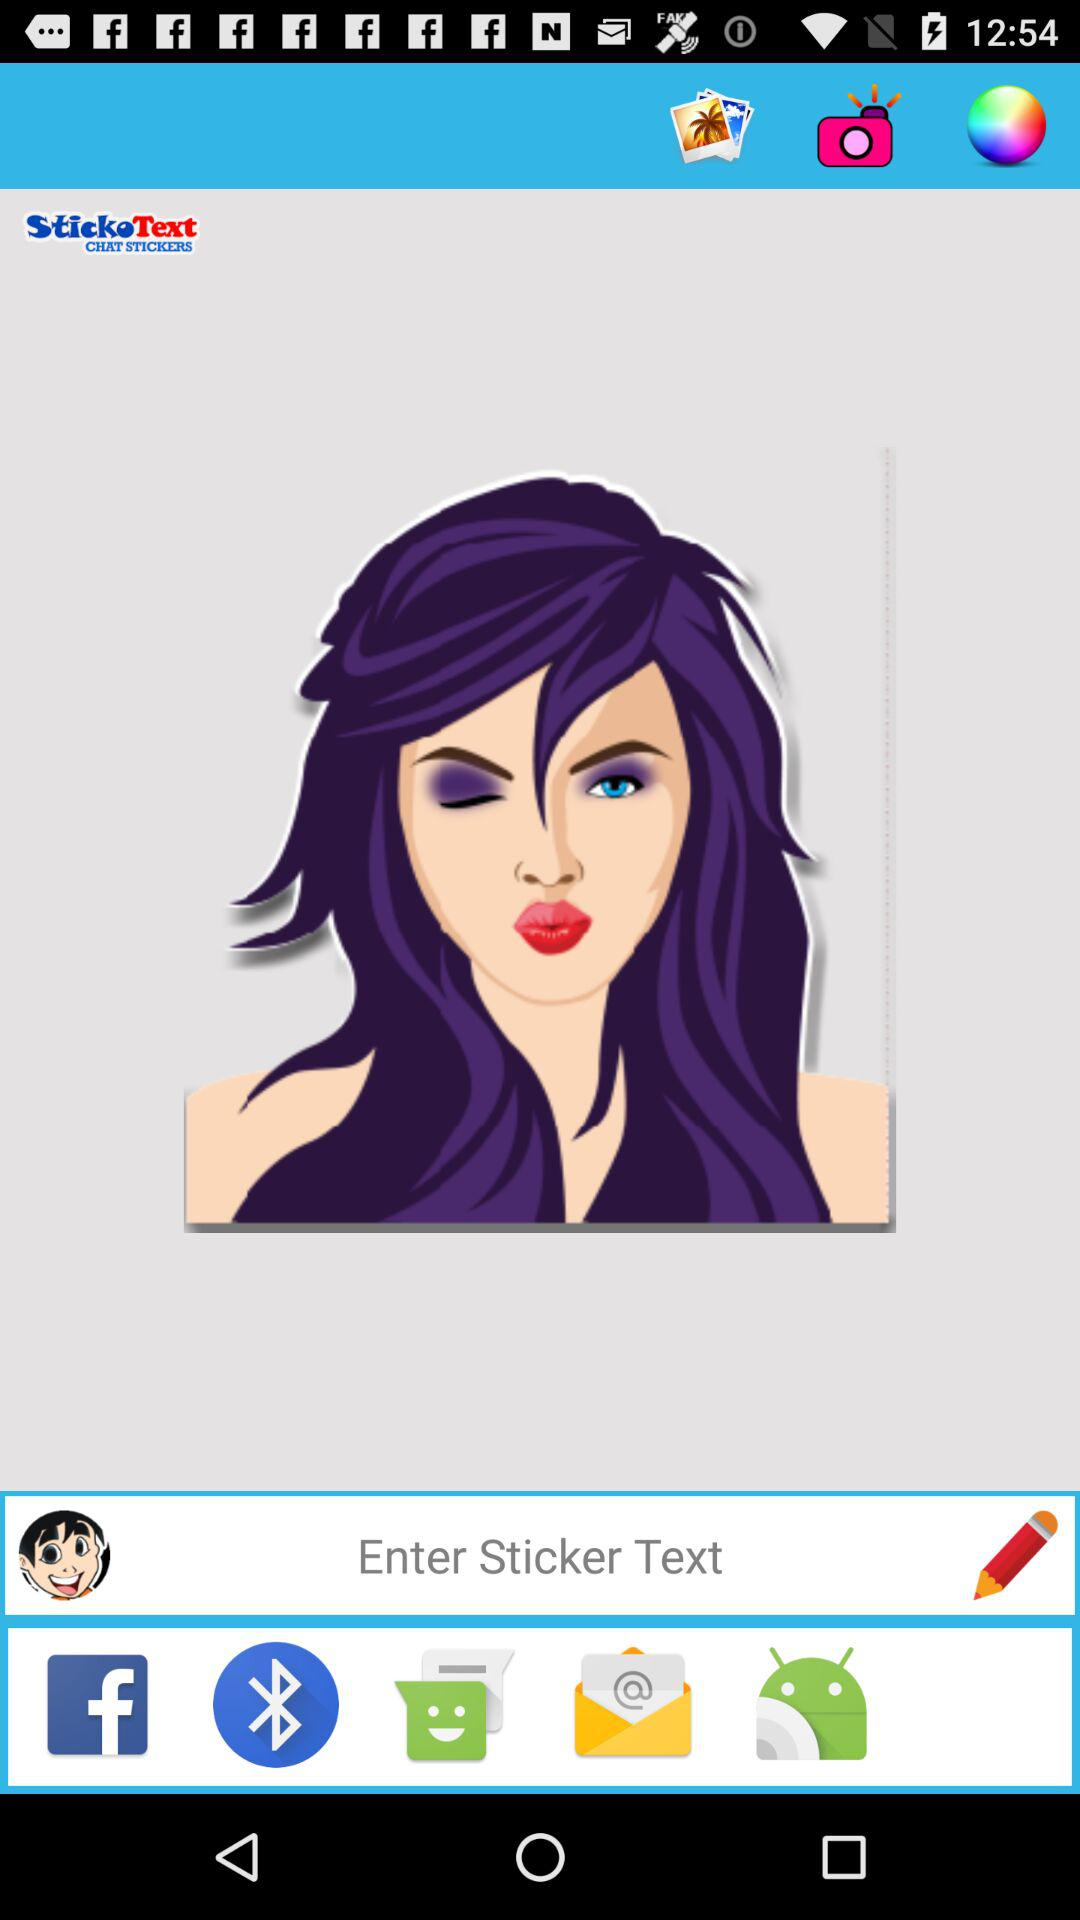What is the application name? The application name is "StickoText". 